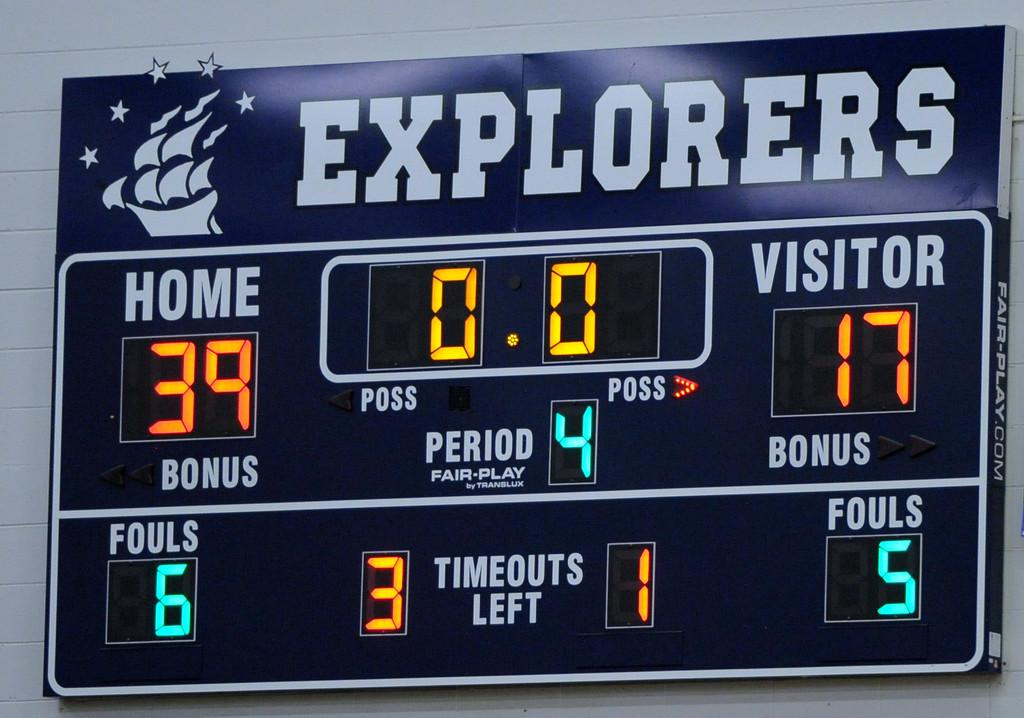<image>
Provide a brief description of the given image. The score for the Explorers game is 39-17. 